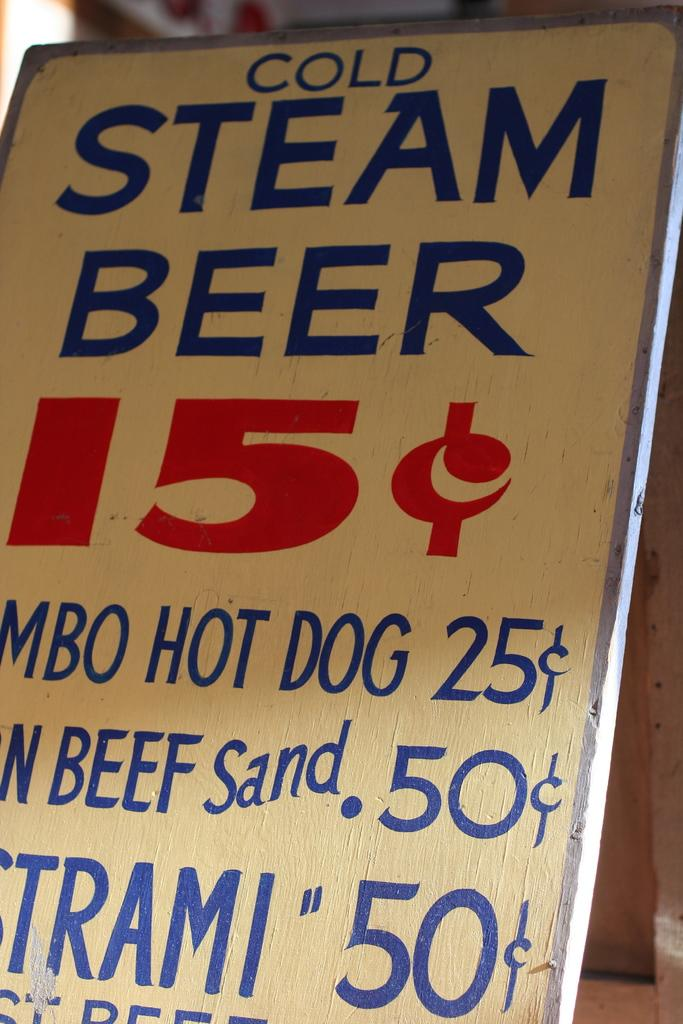Provide a one-sentence caption for the provided image. A sign offering Cold Steam Beer for fifteen cents. 